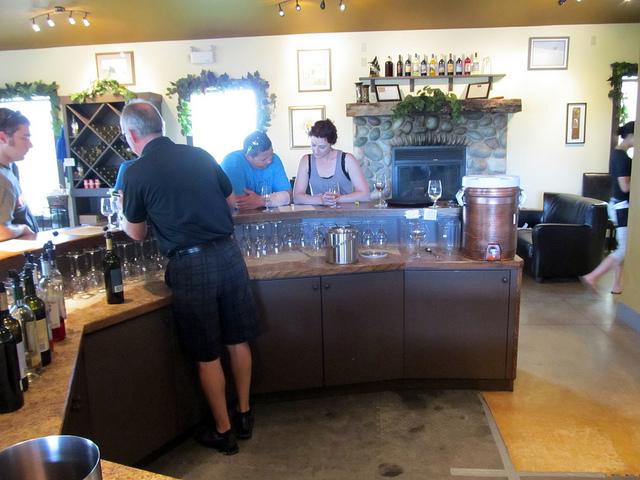What is the man in shorts doing?
Quick response, please. Bartending. How many bottles on the bar?
Answer briefly. 7. Is anyone drinking champagne?
Write a very short answer. No. 